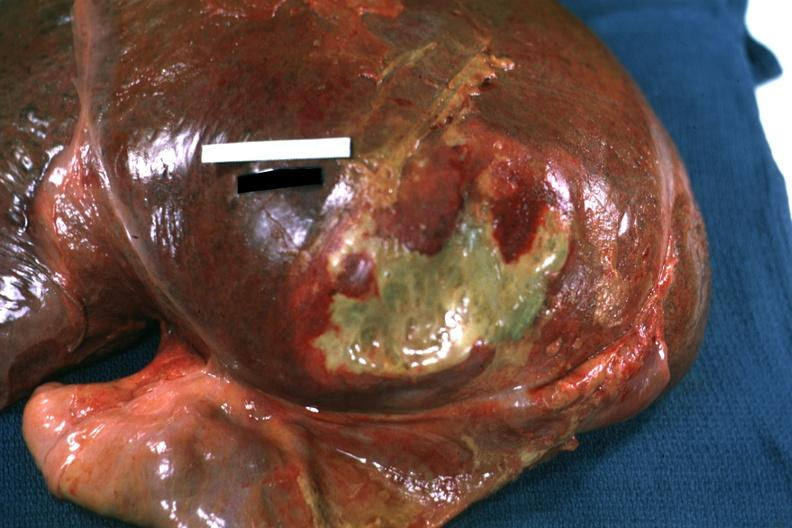does this image show right leaf of diaphragm reflected to show flat mass of yellow green pus quite good example?
Answer the question using a single word or phrase. Yes 